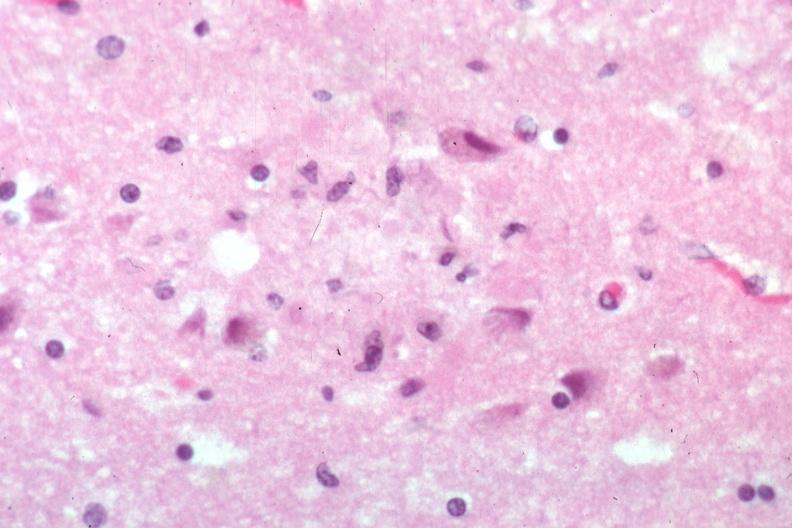s no tissue recognizable as ovary present?
Answer the question using a single word or phrase. No 